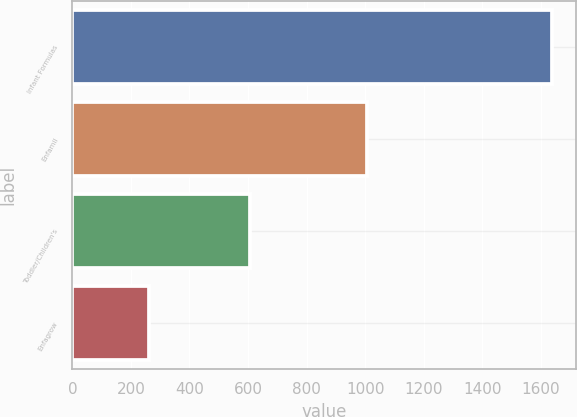Convert chart to OTSL. <chart><loc_0><loc_0><loc_500><loc_500><bar_chart><fcel>Infant Formulas<fcel>Enfamil<fcel>Toddler/Children's<fcel>Enfagrow<nl><fcel>1637<fcel>1007<fcel>606<fcel>262<nl></chart> 